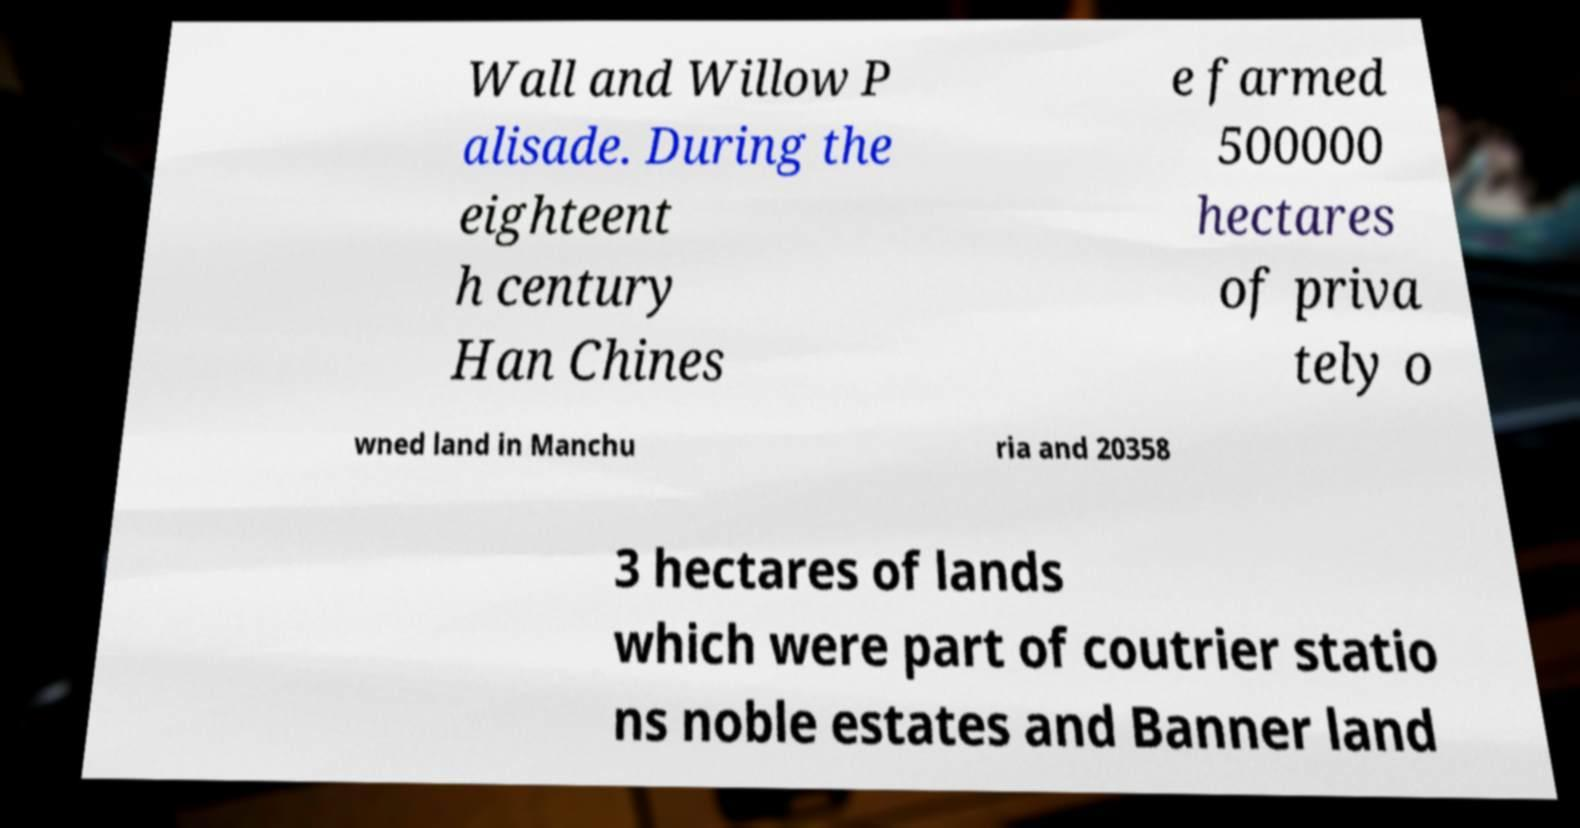Please identify and transcribe the text found in this image. Wall and Willow P alisade. During the eighteent h century Han Chines e farmed 500000 hectares of priva tely o wned land in Manchu ria and 20358 3 hectares of lands which were part of coutrier statio ns noble estates and Banner land 